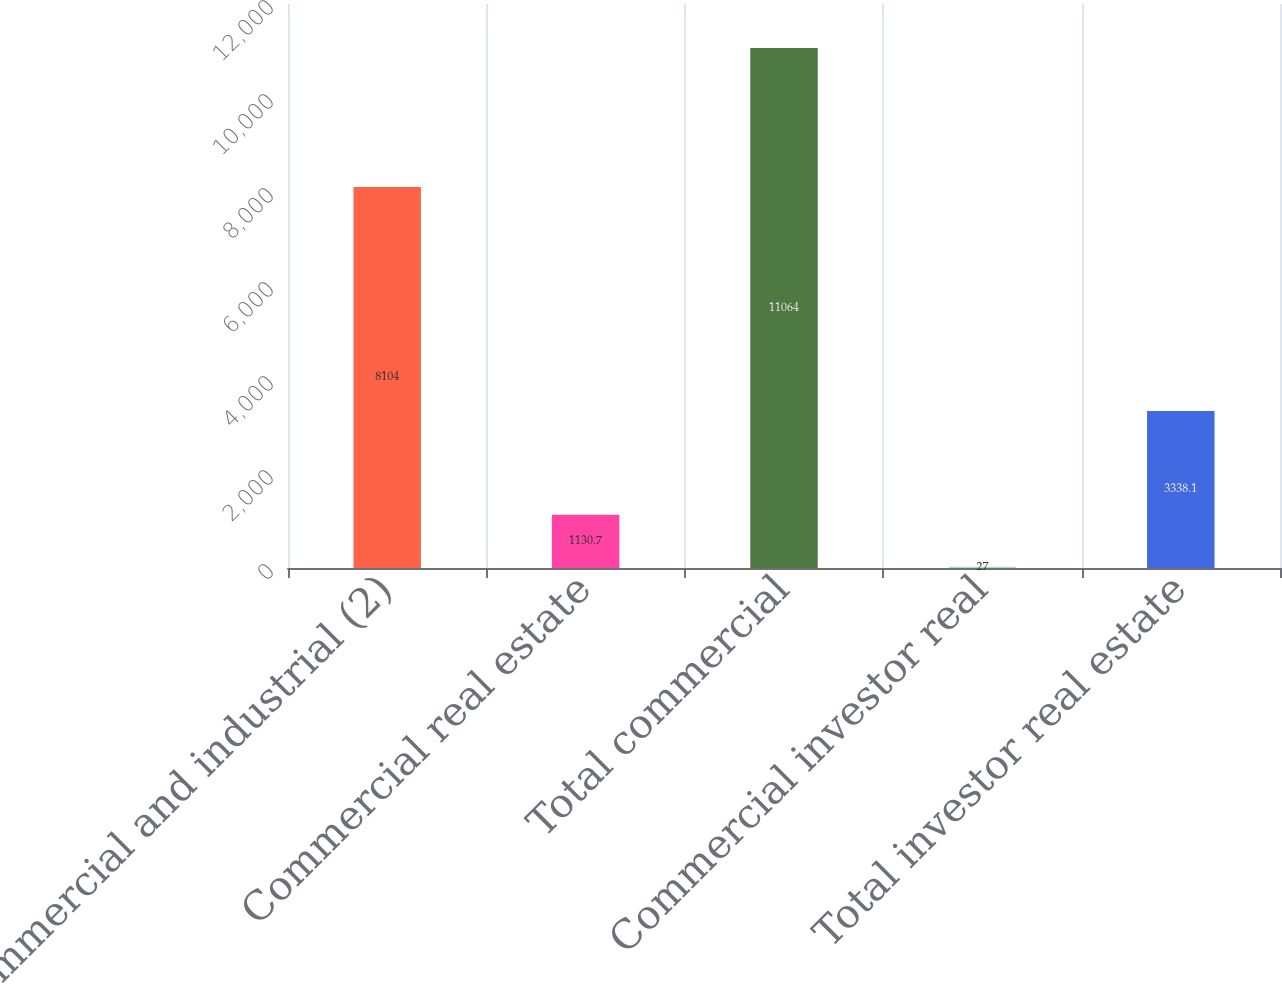Convert chart. <chart><loc_0><loc_0><loc_500><loc_500><bar_chart><fcel>Commercial and industrial (2)<fcel>Commercial real estate<fcel>Total commercial<fcel>Commercial investor real<fcel>Total investor real estate<nl><fcel>8104<fcel>1130.7<fcel>11064<fcel>27<fcel>3338.1<nl></chart> 